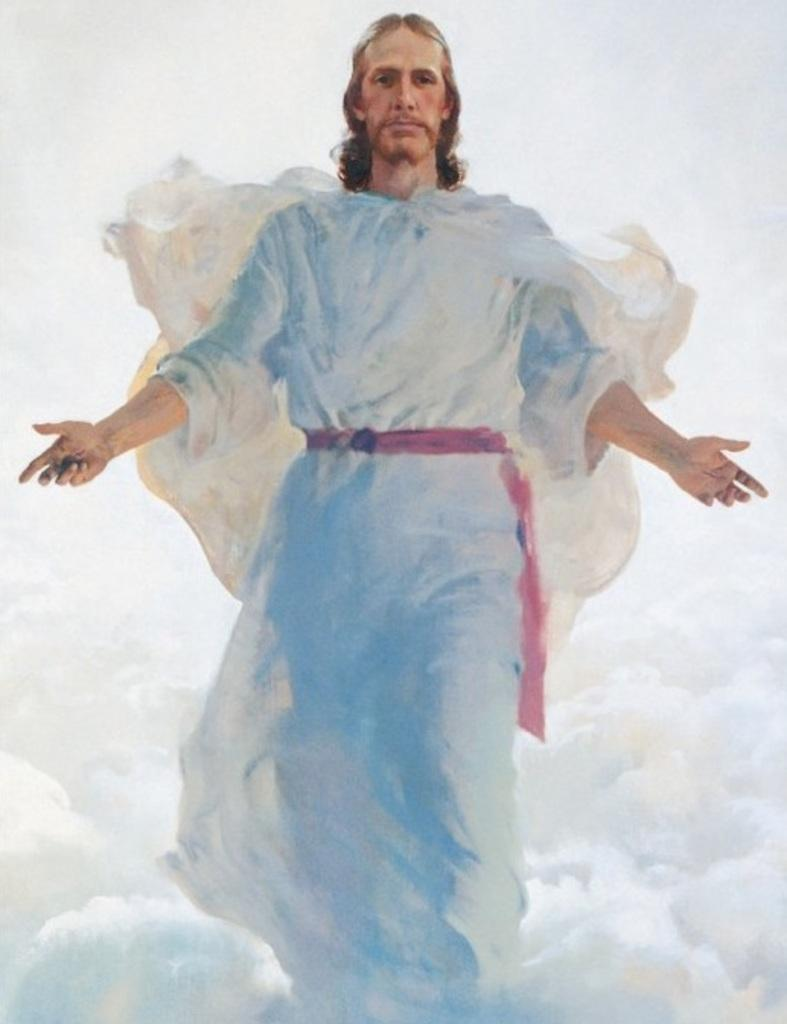What is the main subject of the image? There is a painting in the image. What is the painting depicting? The painting depicts a person standing on clouds. What is the person in the painting wearing or holding? The person in the painting is tied a red cloth around their waist. What type of floor can be seen in the painting? There is no floor visible in the painting, as the person is standing on clouds. Can you tell me how many zebras are present in the painting? There are no zebras depicted in the painting; it features a person standing on clouds. 